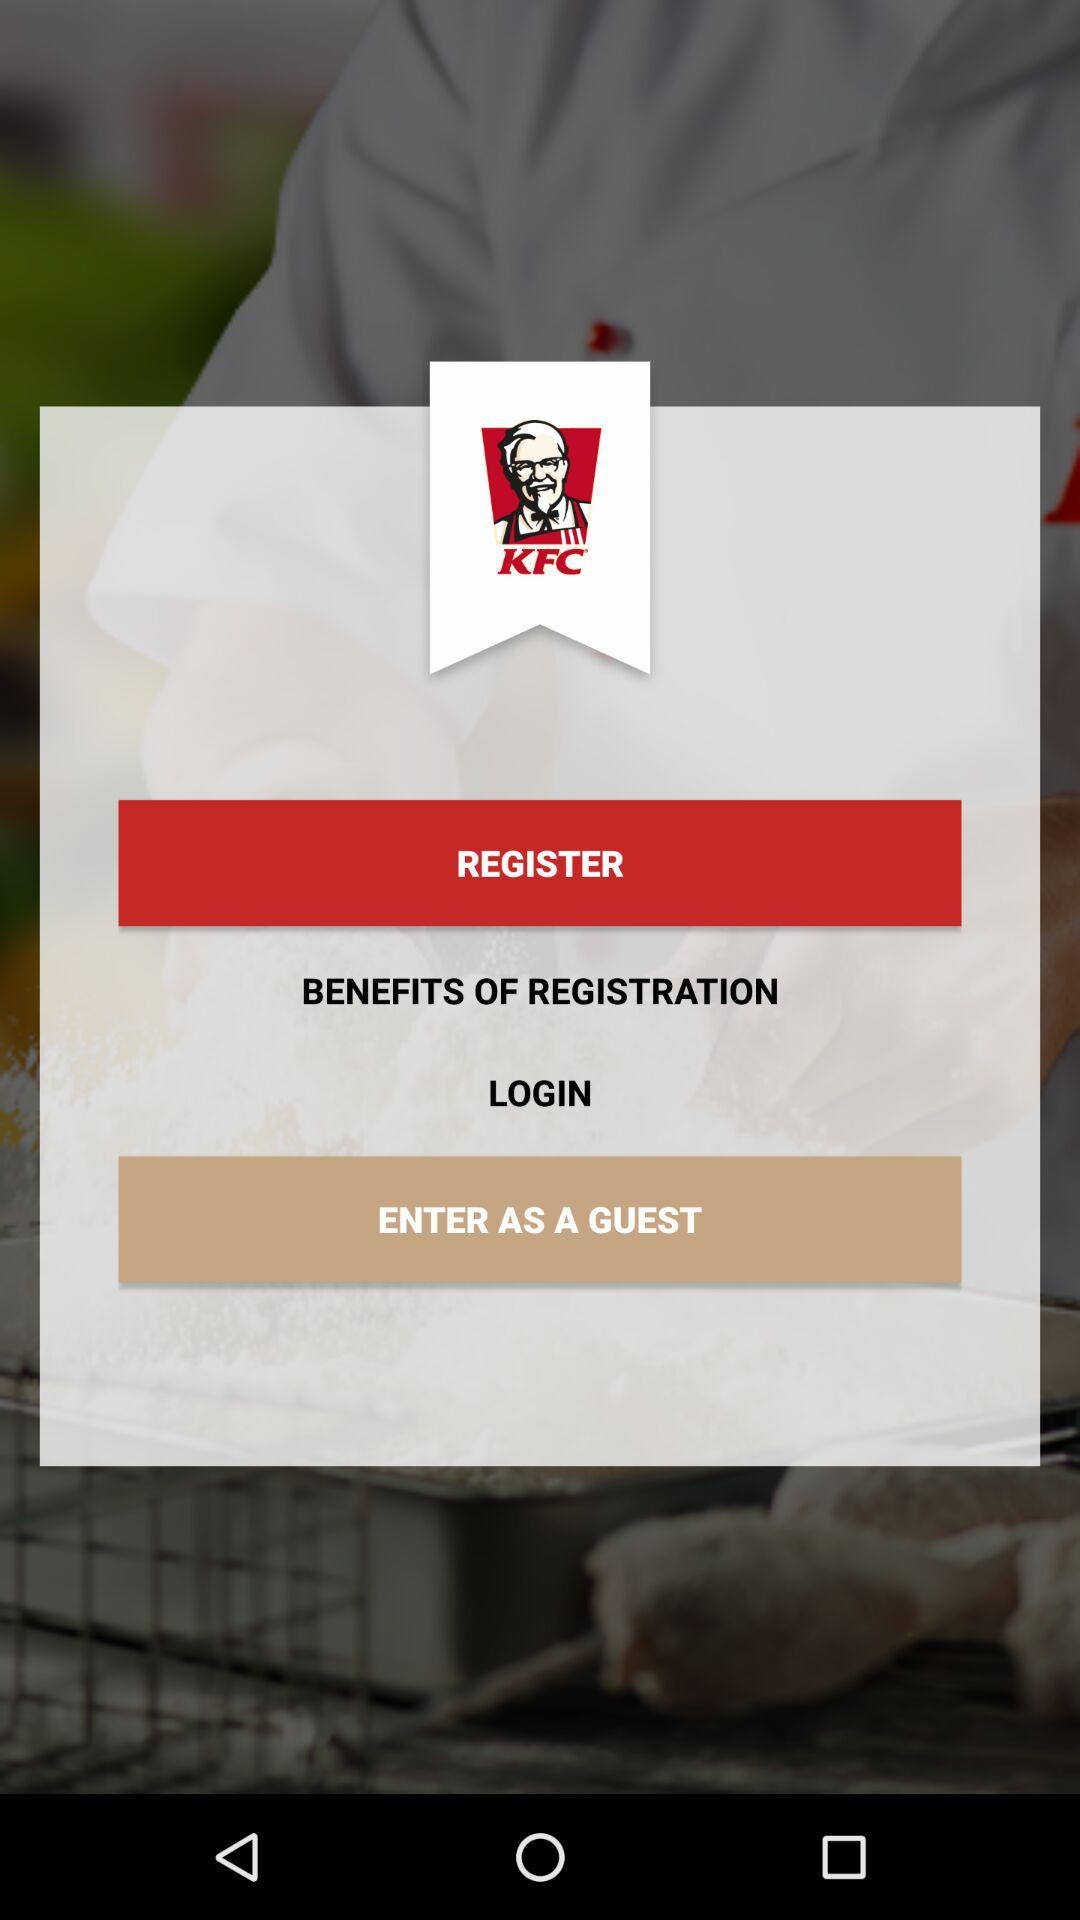What is the name of the application? The name of the application is "KFC". 